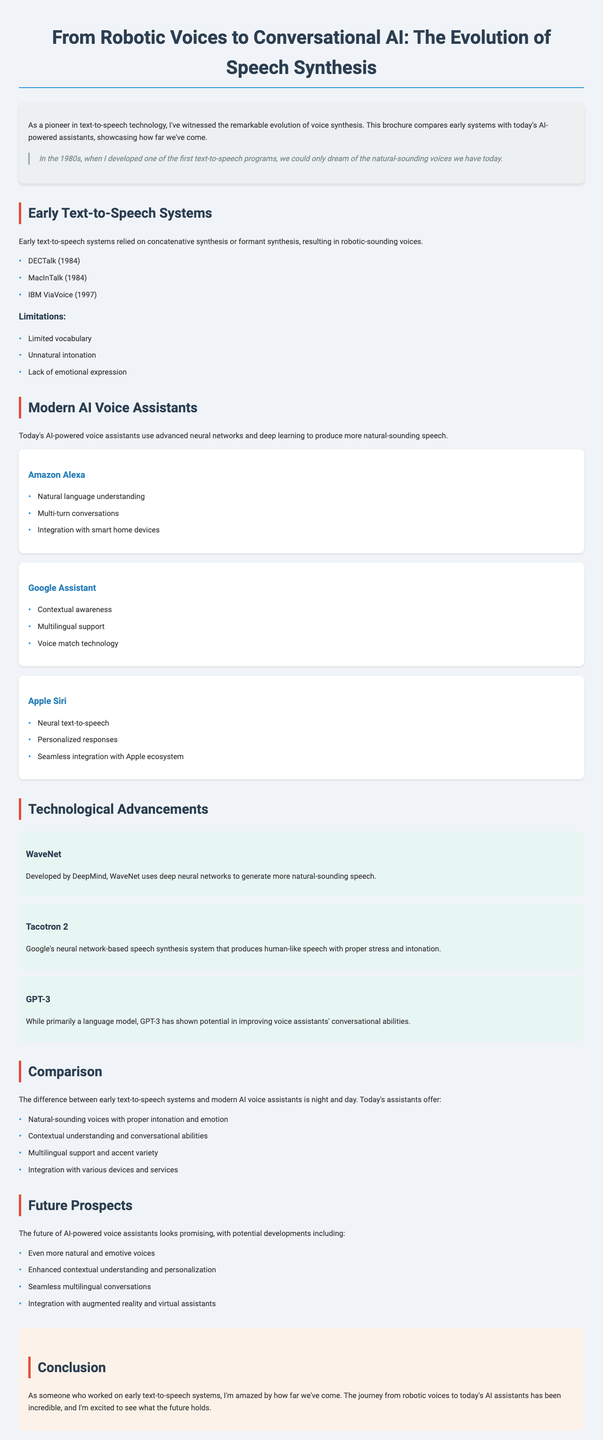What year was DECTalk released? DECTalk was released in 1984, as mentioned in the examples of early text-to-speech systems.
Answer: 1984 Which AI-powered voice assistant is developed by Apple? The document lists Apple Siri as one of the popular AI-powered voice assistants.
Answer: Apple Siri What is one key feature of Google Assistant? The document states "Contextual awareness" as a key feature of Google Assistant.
Answer: Contextual awareness What are the limitations of early text-to-speech systems? The brochure outlines several limitations, including "Limited vocabulary," "Unnatural intonation," and "Lack of emotional expression."
Answer: Limited vocabulary, unnatural intonation, lack of emotional expression What technology developed by DeepMind is mentioned in the brochure? WaveNet is highlighted as a technology developed by DeepMind that generates more natural-sounding speech.
Answer: WaveNet How many popular AI voice assistants are mentioned? The document lists three popular AI voice assistants.
Answer: Three What is expected in the future of AI-powered voice assistants? The brochure mentions possibilities such as "Even more natural and emotive voices" as a future prospect.
Answer: Even more natural and emotive voices What was a contributing technology to neural text-to-speech according to the document? Tacotron 2 is identified as a neural network-based speech synthesis system in the brochure.
Answer: Tacotron 2 What is the primary focus of the brochure? The brochure focuses on comparing early text-to-speech systems with modern AI-powered voice assistants.
Answer: Comparing early text-to-speech systems with modern AI-powered voice assistants 